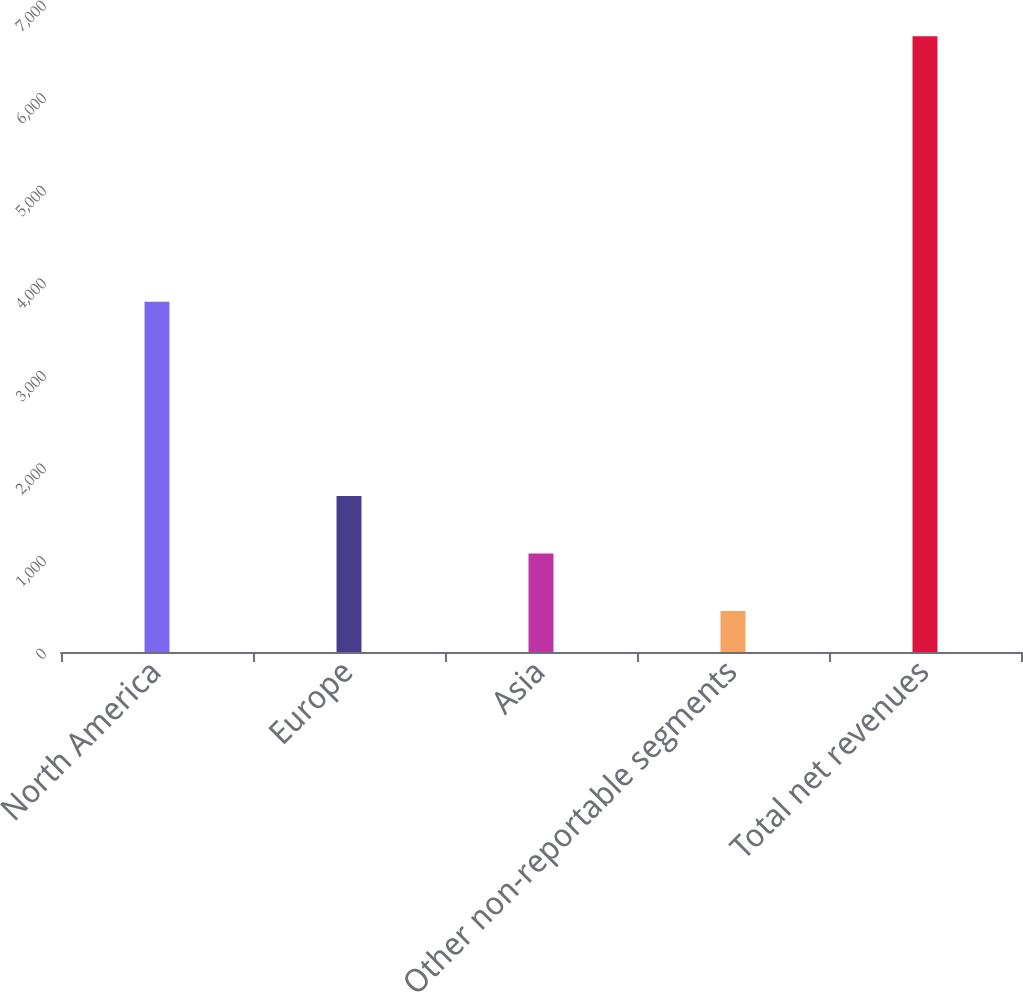Convert chart to OTSL. <chart><loc_0><loc_0><loc_500><loc_500><bar_chart><fcel>North America<fcel>Europe<fcel>Asia<fcel>Other non-reportable segments<fcel>Total net revenues<nl><fcel>3783<fcel>1685.68<fcel>1064.79<fcel>443.9<fcel>6652.8<nl></chart> 